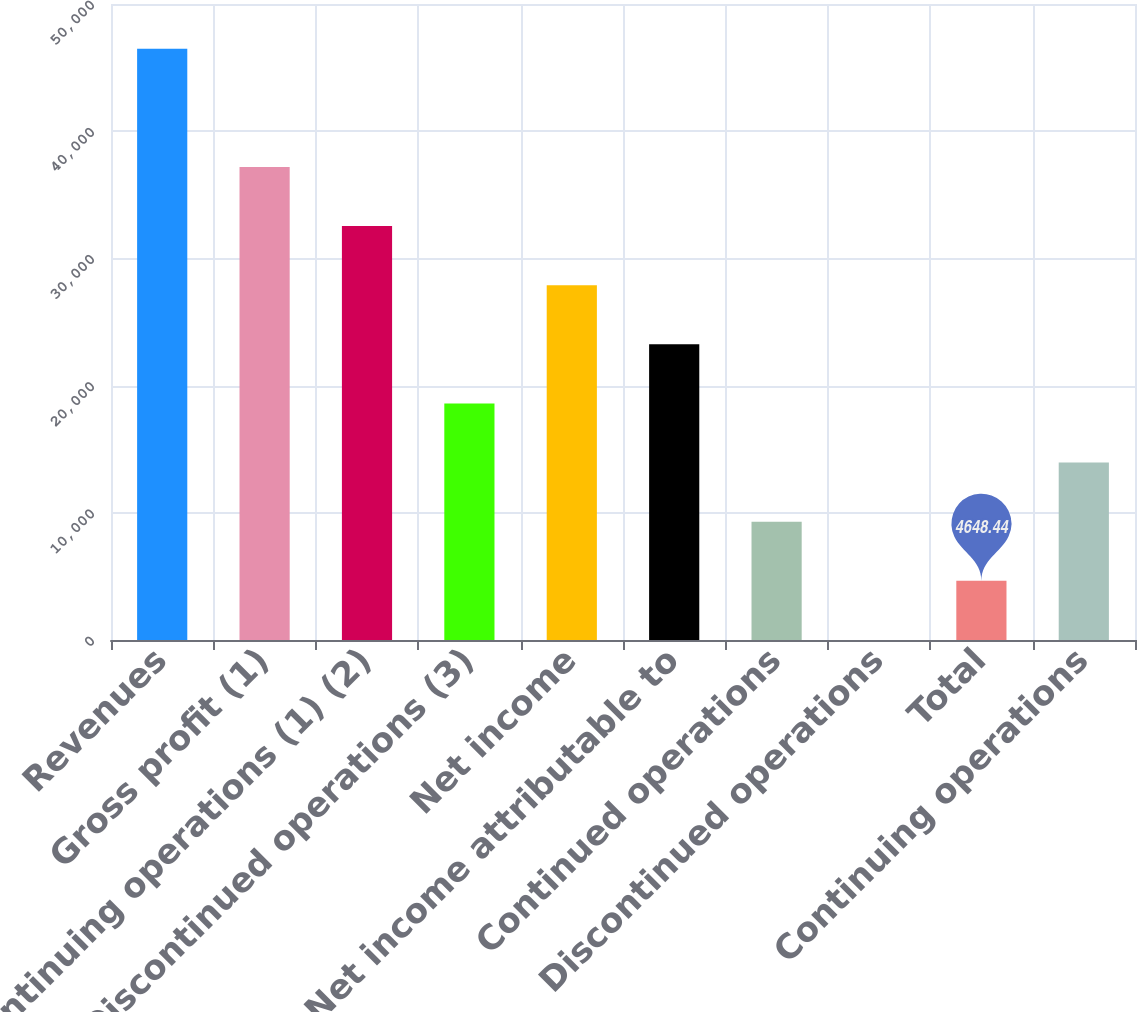Convert chart to OTSL. <chart><loc_0><loc_0><loc_500><loc_500><bar_chart><fcel>Revenues<fcel>Gross profit (1)<fcel>Continuing operations (1) (2)<fcel>Discontinued operations (3)<fcel>Net income<fcel>Net income attributable to<fcel>Continued operations<fcel>Discontinued operations<fcel>Total<fcel>Continuing operations<nl><fcel>46484<fcel>37187.2<fcel>32538.8<fcel>18593.6<fcel>27890.4<fcel>23242<fcel>9296.84<fcel>0.04<fcel>4648.44<fcel>13945.2<nl></chart> 